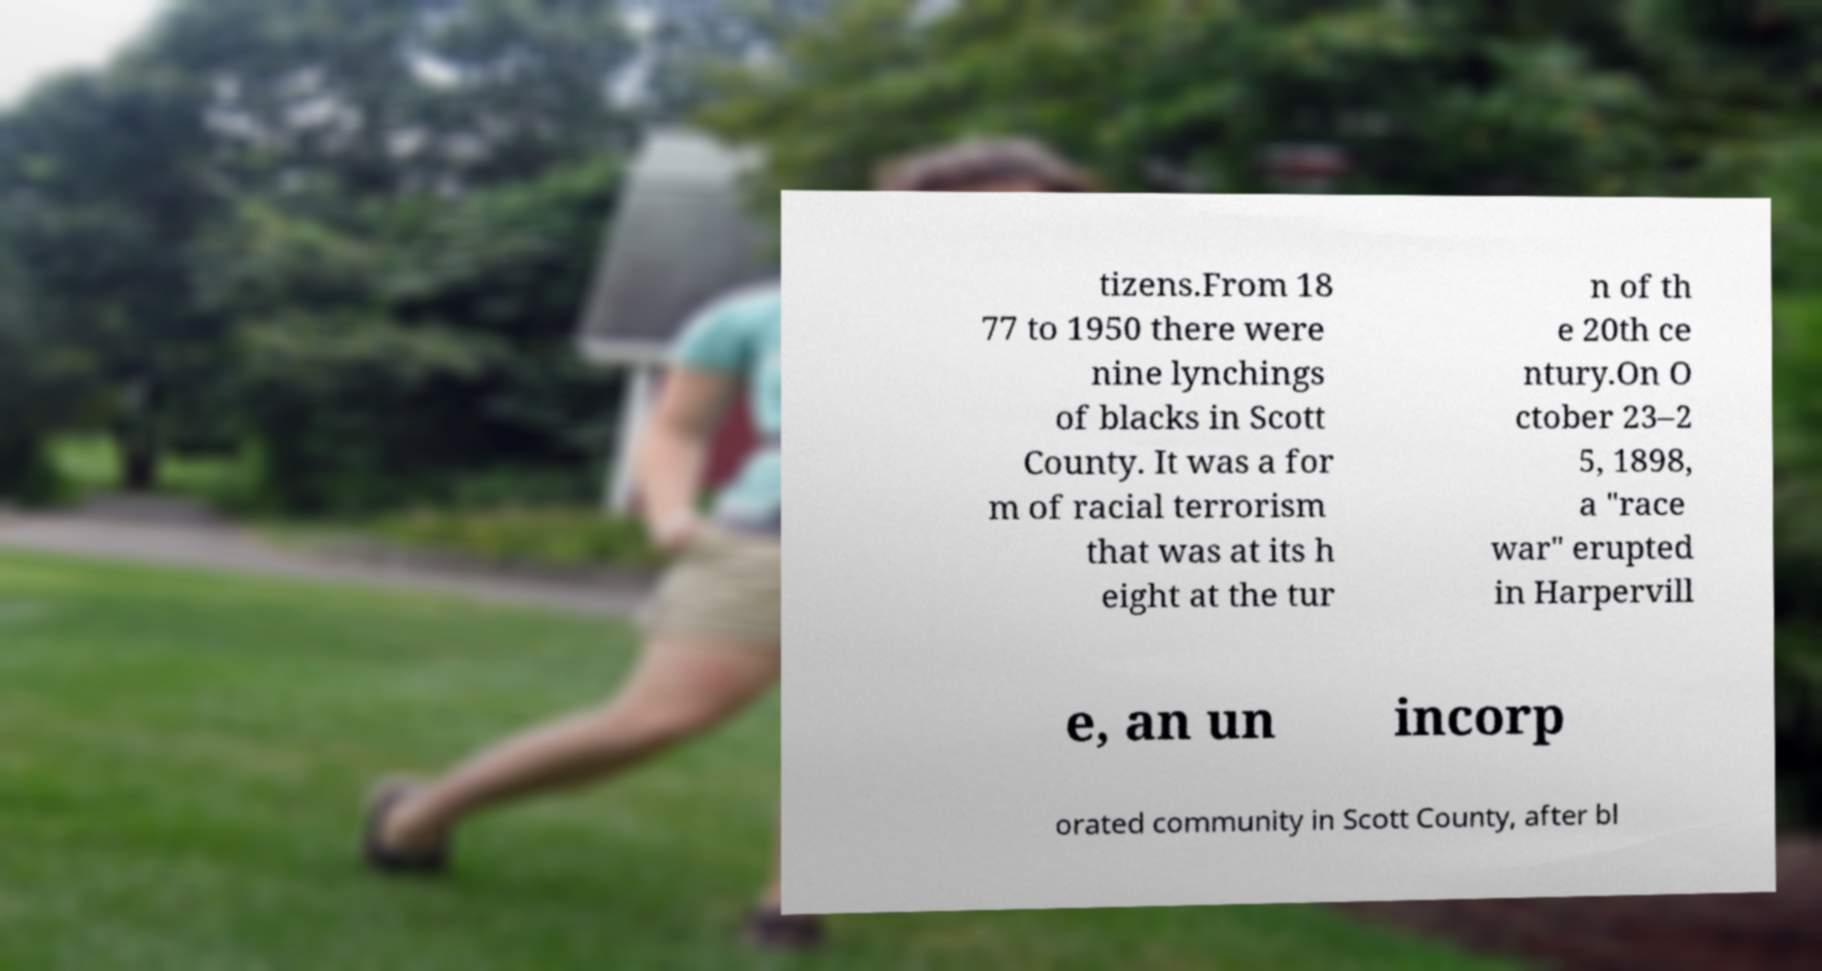Can you read and provide the text displayed in the image?This photo seems to have some interesting text. Can you extract and type it out for me? tizens.From 18 77 to 1950 there were nine lynchings of blacks in Scott County. It was a for m of racial terrorism that was at its h eight at the tur n of th e 20th ce ntury.On O ctober 23–2 5, 1898, a "race war" erupted in Harpervill e, an un incorp orated community in Scott County, after bl 